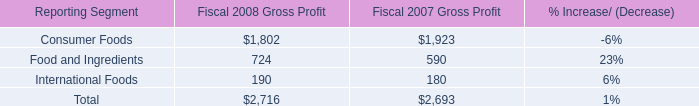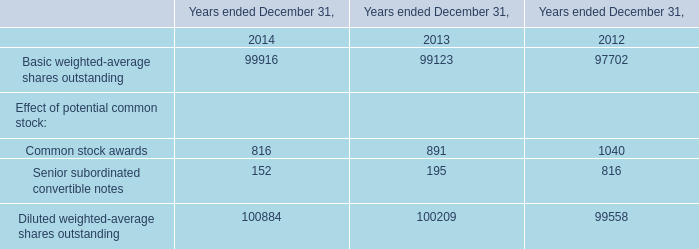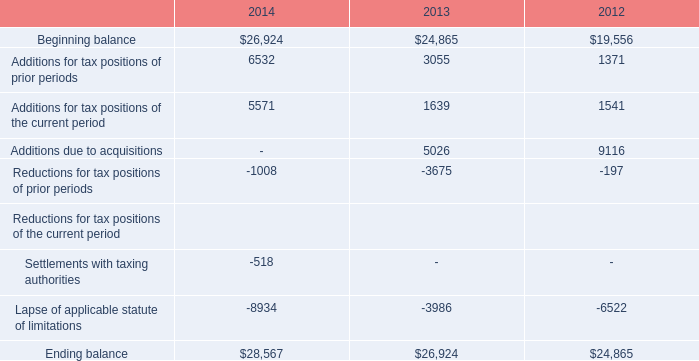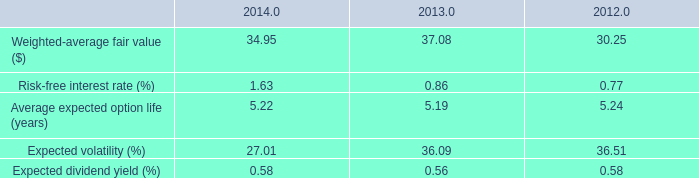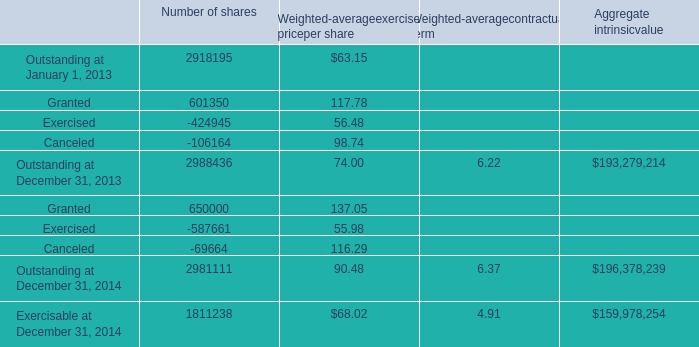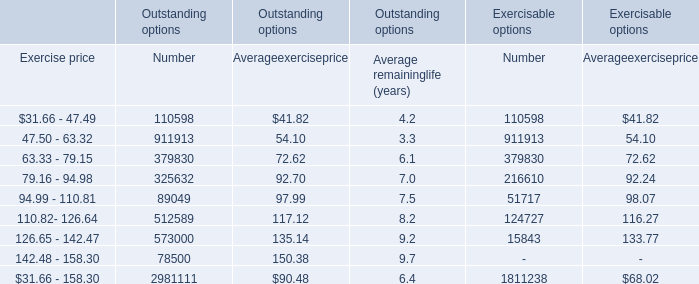If Granted for number of shares develops with the same growth rate in 2014, what will it reach in 2015? 
Computations: ((((650000 - 601350) / 601350) + 1) * 650000)
Answer: 702585.84851. 